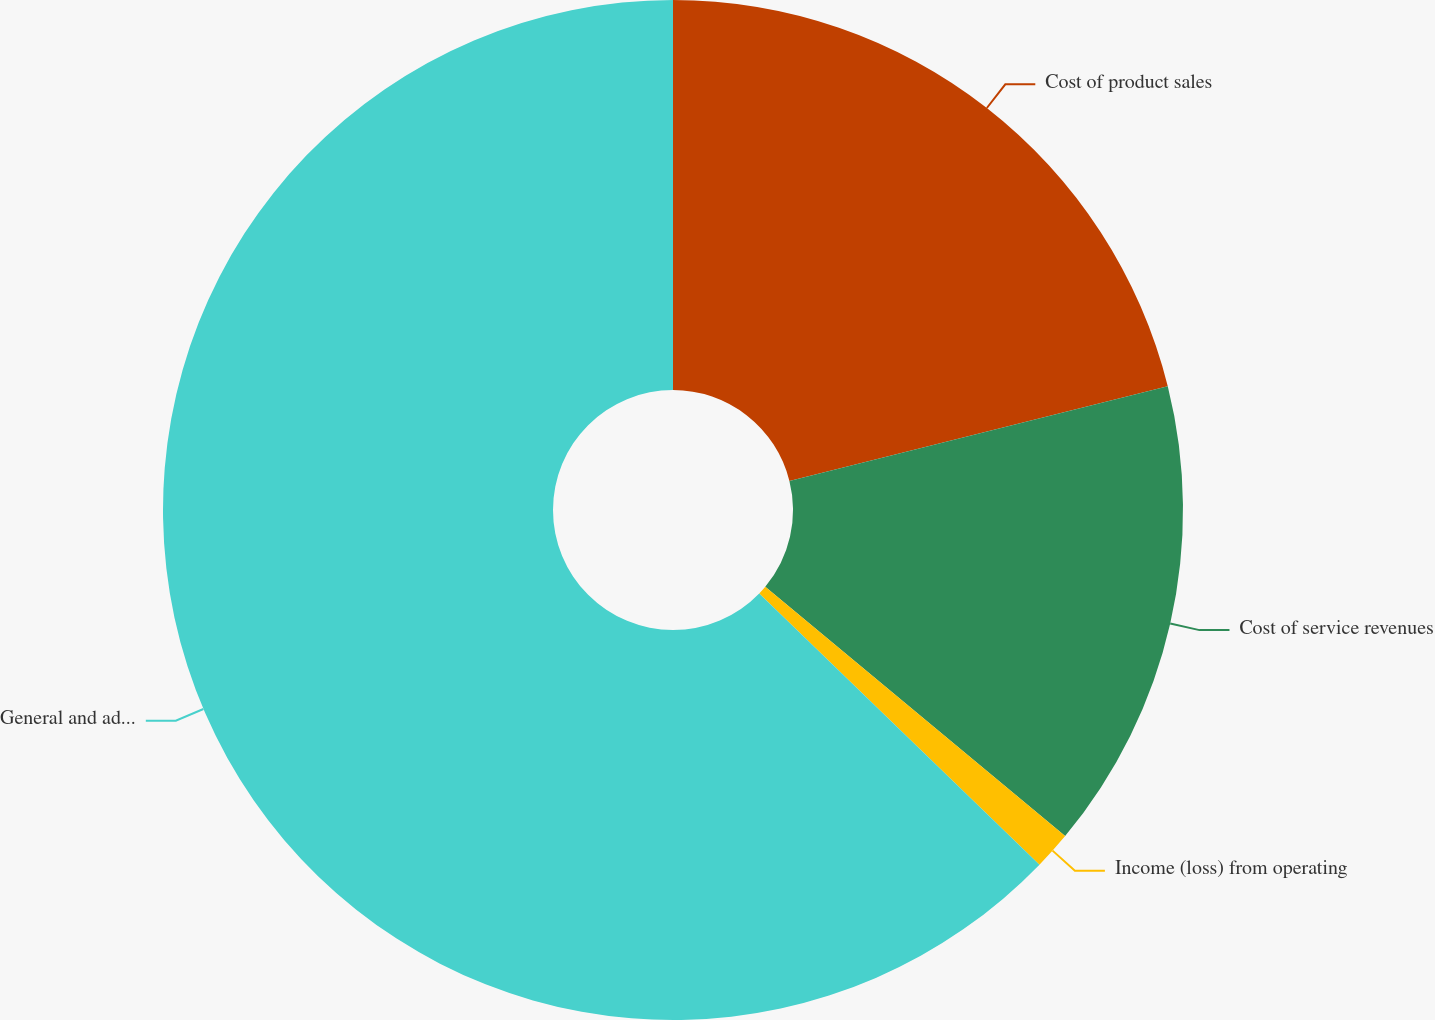Convert chart. <chart><loc_0><loc_0><loc_500><loc_500><pie_chart><fcel>Cost of product sales<fcel>Cost of service revenues<fcel>Income (loss) from operating<fcel>General and administrative<nl><fcel>21.1%<fcel>14.94%<fcel>1.2%<fcel>62.76%<nl></chart> 